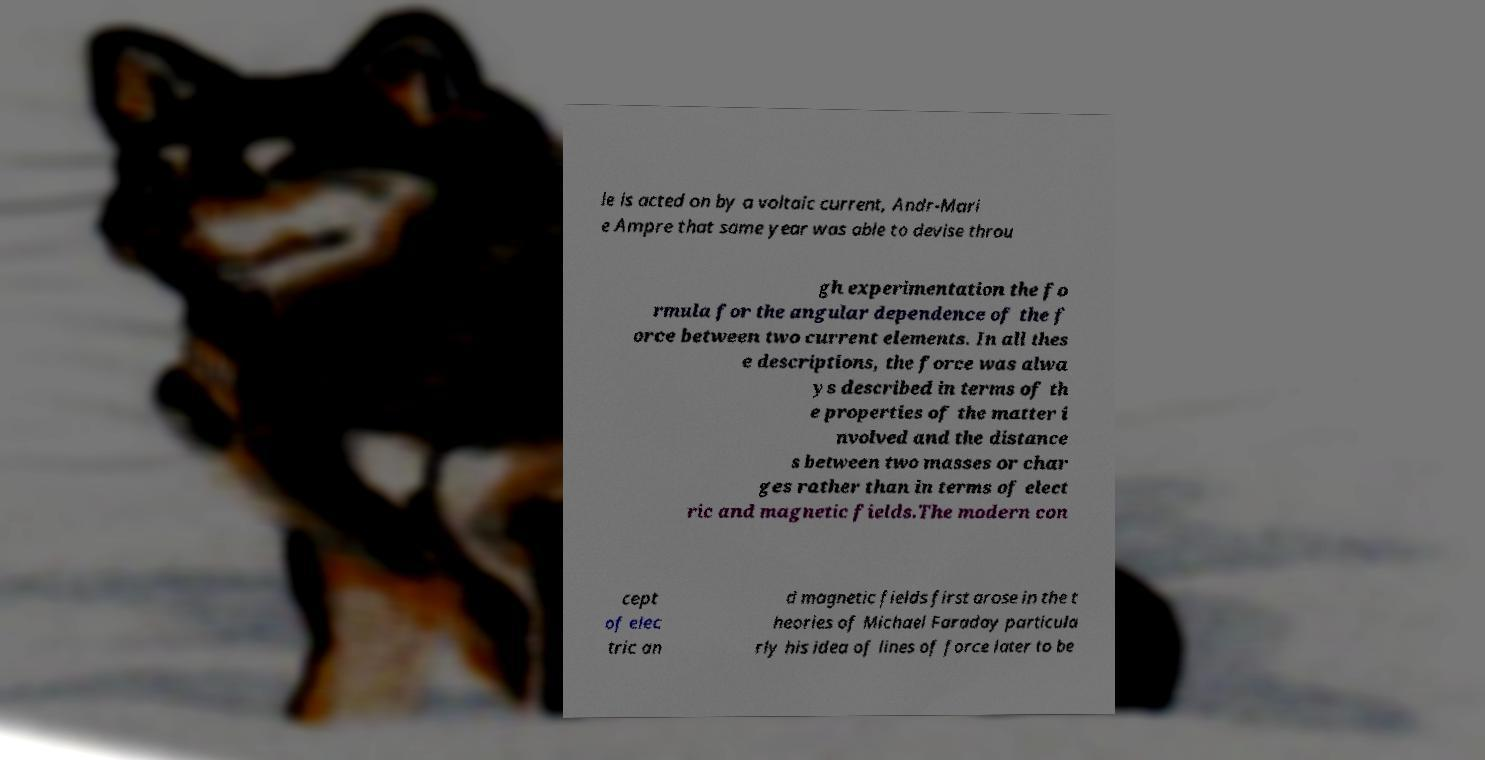I need the written content from this picture converted into text. Can you do that? le is acted on by a voltaic current, Andr-Mari e Ampre that same year was able to devise throu gh experimentation the fo rmula for the angular dependence of the f orce between two current elements. In all thes e descriptions, the force was alwa ys described in terms of th e properties of the matter i nvolved and the distance s between two masses or char ges rather than in terms of elect ric and magnetic fields.The modern con cept of elec tric an d magnetic fields first arose in the t heories of Michael Faraday particula rly his idea of lines of force later to be 